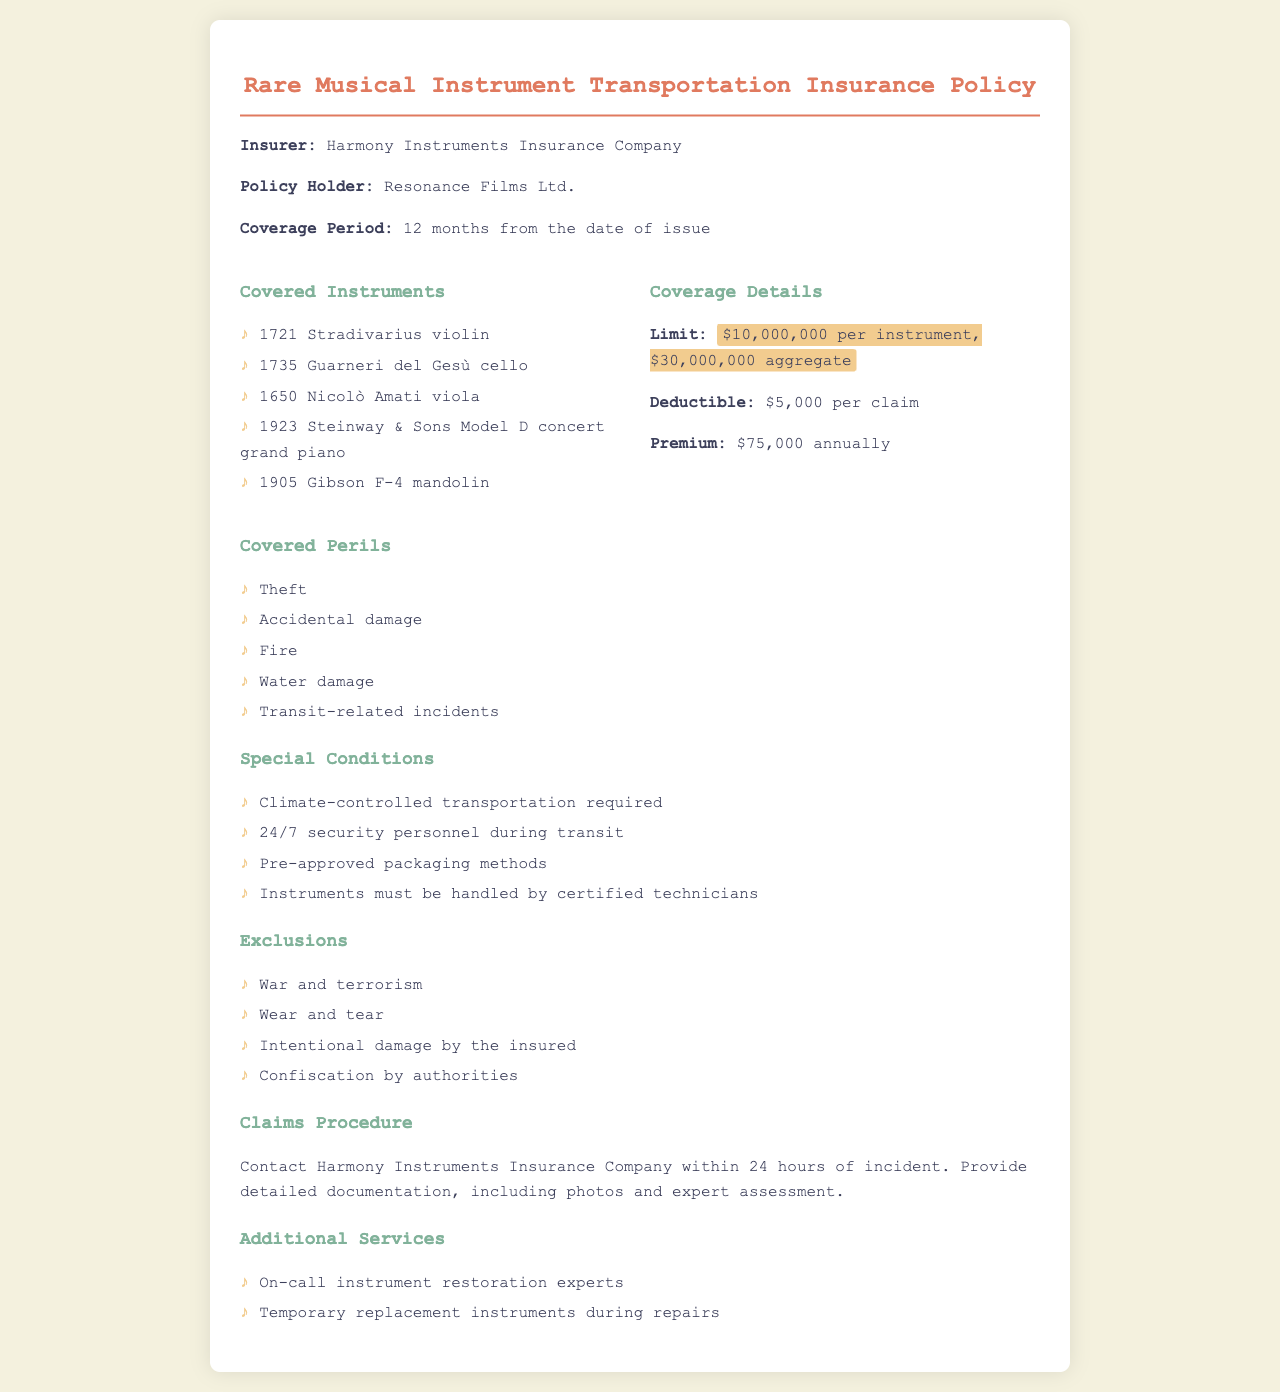what is the policy limit for each instrument? The policy document specifies a coverage limit of $10,000,000 per instrument.
Answer: $10,000,000 what is the annual premium for the insurance? The annual premium according to the coverage details in the document is stated as $75,000.
Answer: $75,000 who is the insurer mentioned in the policy? The insurer listed in the document is Harmony Instruments Insurance Company.
Answer: Harmony Instruments Insurance Company what are the exclusions related to this insurance policy? The document outlines exclusions such as war and terrorism, wear and tear, intentional damage by the insured, and confiscation by authorities.
Answer: War and terrorism, wear and tear, intentional damage by the insured, confiscation by authorities how long is the coverage period of the policy? The coverage period is mentioned as 12 months from the date of issue.
Answer: 12 months what is required during the transportation of the instruments? The special conditions state that climate-controlled transportation is required during the travel of the instruments.
Answer: Climate-controlled transportation how soon must a claim be reported after an incident? The claims procedure states that incidents must be reported within 24 hours.
Answer: 24 hours what type of instruments are covered under this policy? The covered instruments include specific valuable musical items like the 1721 Stradivarius violin and 1923 Steinway & Sons Model D concert grand piano.
Answer: 1721 Stradivarius violin, 1923 Steinway & Sons Model D concert grand piano 